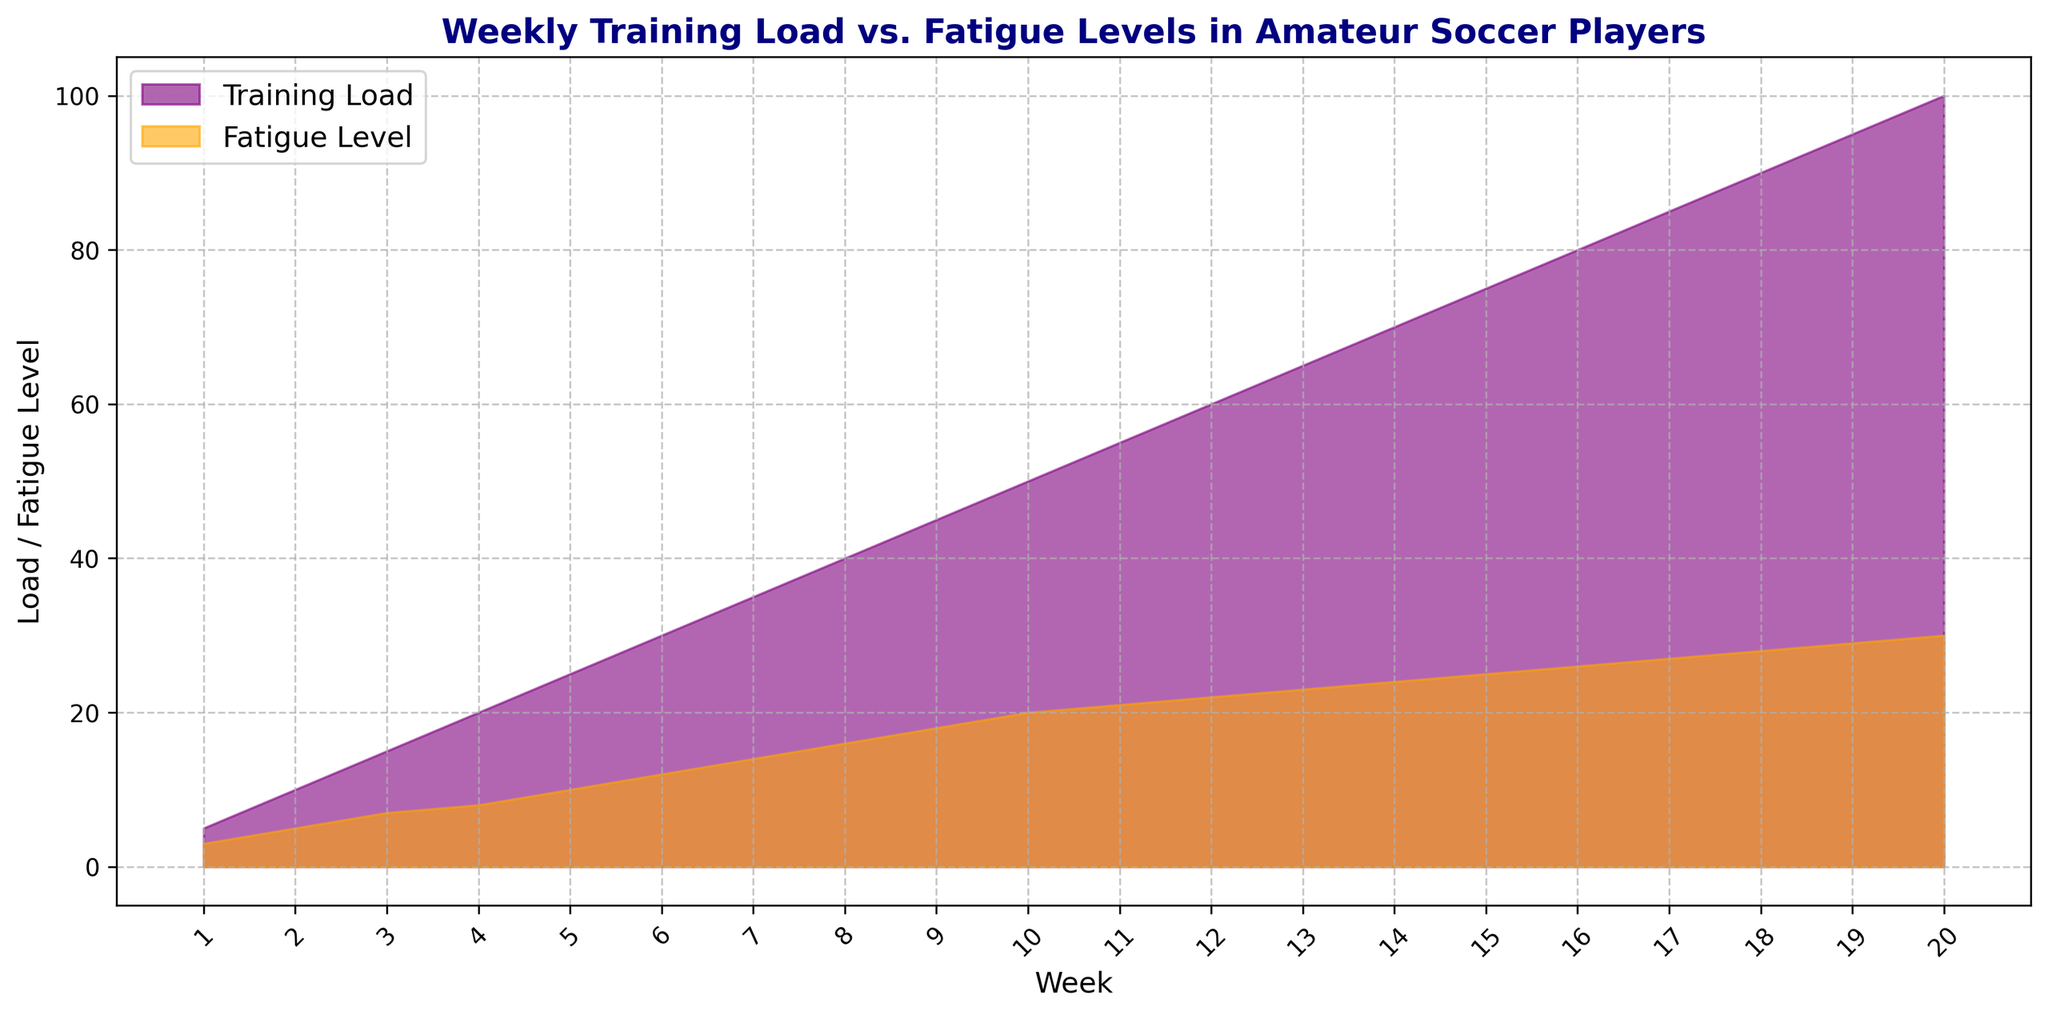What's the difference between the Training Load and Fatigue Level at Week 10? Look at Week 10 on the x-axis. Training Load is 50, and Fatigue Level is 20. The difference is 50 - 20 = 30.
Answer: 30 How does the Fatigue Level trend change over Weeks 1 to 20? From Week 1 to Week 20, the fatigue level steadily increases. This is visually shown by an upward trend in the orange shaded area.
Answer: Steadily increases At which week do both Training Load and Fatigue Level reach the highest values? Look at the end of the x-axis (Week 20). This is where both the purple and orange areas reach their maximum heights.
Answer: Week 20 Is the rate of increase in Training Load and Fatigue Level consistent throughout the weeks? Visually compare the slopes of both Training Load and Fatigue Level areas. Both areas show a consistently steady increase without sudden spikes or dips.
Answer: Yes At Week 5, what proportion of Fatigue Level to Training Load can be observed? At Week 5, the Training Load is 25, and the Fatigue Level is 10. Calculate the proportion as 10/25 = 0.4 or 40%.
Answer: 40% Between Week 9 and Week 10, how much does the Fatigue Level increase by? Check the values at Week 9 and Week 10: Fatigue Level goes from 18 to 20. The increase is 20 - 18 = 2.
Answer: 2 Which week shows a higher increase in Training Load compared to Fatigue Level, Week 4 to Week 5 or Week 12 to Week 13? Week 4 to Week 5: Training Load increases by 5 (25-20), and Fatigue Level increases by 2 (10-8). Week 12 to Week 13: Training Load increases by 5 (65-60), and Fatigue Level increases by 1 (23-22). Compare the increases.
Answer: Week 4 to Week 5 At Week 15, how does the height of the Training Load compare to the Fatigue Level on the plot? At Week 15, visually measure the height of the purple (Training Load) and orange (Fatigue Level) areas. Training Load is significantly higher, reaching 75 while Fatigue Level is at 25.
Answer: Training Load is higher What's the average Training Load over the first 10 weeks? Sum the Training Load values from Week 1 to Week 10: (5 + 10 + 15 + 20 + 25 + 30 + 35 + 40 + 45 + 50) = 275. Divide by 10: 275/10 = 27.5.
Answer: 27.5 When does the Training Load exceed 50 for the first time? Find the week where the Training Load first crosses 50. From the data, it happens at Week 11.
Answer: Week 11 